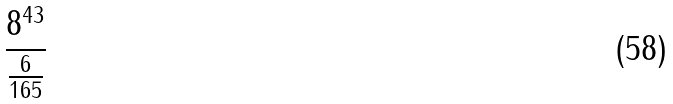<formula> <loc_0><loc_0><loc_500><loc_500>\frac { 8 ^ { 4 3 } } { \frac { 6 } { 1 6 5 } }</formula> 